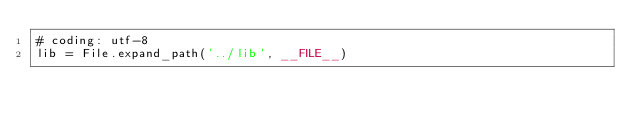<code> <loc_0><loc_0><loc_500><loc_500><_Ruby_># coding: utf-8
lib = File.expand_path('../lib', __FILE__)</code> 